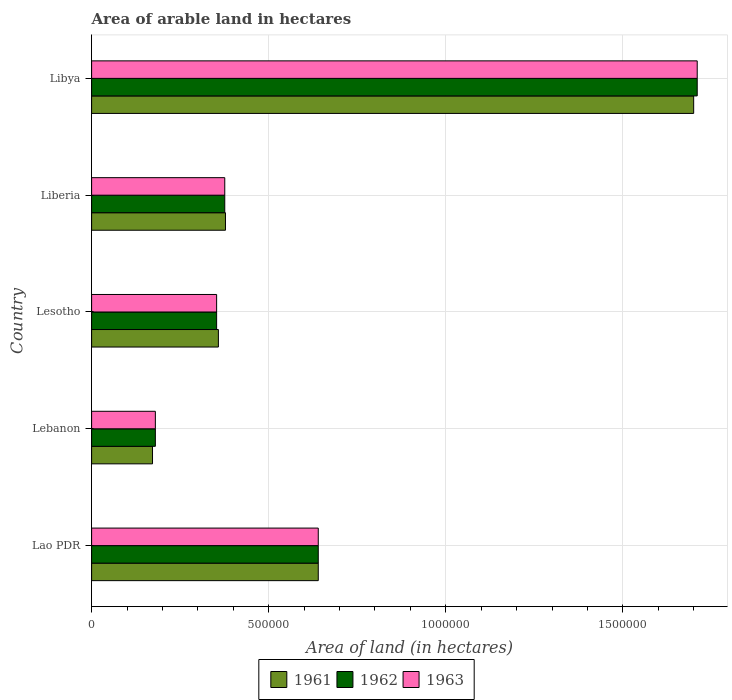How many different coloured bars are there?
Your answer should be very brief. 3. How many groups of bars are there?
Make the answer very short. 5. How many bars are there on the 4th tick from the top?
Your answer should be compact. 3. How many bars are there on the 3rd tick from the bottom?
Give a very brief answer. 3. What is the label of the 2nd group of bars from the top?
Offer a terse response. Liberia. In how many cases, is the number of bars for a given country not equal to the number of legend labels?
Provide a short and direct response. 0. What is the total arable land in 1962 in Libya?
Offer a terse response. 1.71e+06. Across all countries, what is the maximum total arable land in 1962?
Provide a succinct answer. 1.71e+06. Across all countries, what is the minimum total arable land in 1962?
Keep it short and to the point. 1.80e+05. In which country was the total arable land in 1962 maximum?
Your response must be concise. Libya. In which country was the total arable land in 1962 minimum?
Offer a very short reply. Lebanon. What is the total total arable land in 1962 in the graph?
Give a very brief answer. 3.26e+06. What is the difference between the total arable land in 1963 in Lesotho and that in Liberia?
Keep it short and to the point. -2.30e+04. What is the difference between the total arable land in 1962 in Lesotho and the total arable land in 1961 in Lebanon?
Ensure brevity in your answer.  1.81e+05. What is the average total arable land in 1962 per country?
Your answer should be very brief. 6.52e+05. In how many countries, is the total arable land in 1963 greater than 1600000 hectares?
Your answer should be very brief. 1. What is the ratio of the total arable land in 1963 in Lebanon to that in Libya?
Your response must be concise. 0.11. What is the difference between the highest and the second highest total arable land in 1963?
Provide a short and direct response. 1.07e+06. What is the difference between the highest and the lowest total arable land in 1961?
Offer a terse response. 1.53e+06. What does the 1st bar from the top in Liberia represents?
Give a very brief answer. 1963. How many bars are there?
Ensure brevity in your answer.  15. Are all the bars in the graph horizontal?
Give a very brief answer. Yes. How many countries are there in the graph?
Make the answer very short. 5. Are the values on the major ticks of X-axis written in scientific E-notation?
Offer a terse response. No. Does the graph contain grids?
Your answer should be very brief. Yes. Where does the legend appear in the graph?
Make the answer very short. Bottom center. How are the legend labels stacked?
Provide a short and direct response. Horizontal. What is the title of the graph?
Provide a succinct answer. Area of arable land in hectares. What is the label or title of the X-axis?
Keep it short and to the point. Area of land (in hectares). What is the label or title of the Y-axis?
Provide a succinct answer. Country. What is the Area of land (in hectares) in 1961 in Lao PDR?
Give a very brief answer. 6.40e+05. What is the Area of land (in hectares) in 1962 in Lao PDR?
Your answer should be compact. 6.40e+05. What is the Area of land (in hectares) of 1963 in Lao PDR?
Provide a short and direct response. 6.40e+05. What is the Area of land (in hectares) in 1961 in Lebanon?
Your answer should be very brief. 1.72e+05. What is the Area of land (in hectares) of 1962 in Lebanon?
Give a very brief answer. 1.80e+05. What is the Area of land (in hectares) in 1961 in Lesotho?
Provide a succinct answer. 3.58e+05. What is the Area of land (in hectares) of 1962 in Lesotho?
Keep it short and to the point. 3.53e+05. What is the Area of land (in hectares) in 1963 in Lesotho?
Make the answer very short. 3.53e+05. What is the Area of land (in hectares) in 1961 in Liberia?
Provide a short and direct response. 3.78e+05. What is the Area of land (in hectares) in 1962 in Liberia?
Give a very brief answer. 3.76e+05. What is the Area of land (in hectares) of 1963 in Liberia?
Ensure brevity in your answer.  3.76e+05. What is the Area of land (in hectares) in 1961 in Libya?
Your answer should be very brief. 1.70e+06. What is the Area of land (in hectares) in 1962 in Libya?
Give a very brief answer. 1.71e+06. What is the Area of land (in hectares) in 1963 in Libya?
Provide a succinct answer. 1.71e+06. Across all countries, what is the maximum Area of land (in hectares) in 1961?
Your response must be concise. 1.70e+06. Across all countries, what is the maximum Area of land (in hectares) in 1962?
Provide a succinct answer. 1.71e+06. Across all countries, what is the maximum Area of land (in hectares) in 1963?
Offer a terse response. 1.71e+06. Across all countries, what is the minimum Area of land (in hectares) of 1961?
Your response must be concise. 1.72e+05. Across all countries, what is the minimum Area of land (in hectares) in 1962?
Offer a terse response. 1.80e+05. What is the total Area of land (in hectares) of 1961 in the graph?
Ensure brevity in your answer.  3.25e+06. What is the total Area of land (in hectares) of 1962 in the graph?
Keep it short and to the point. 3.26e+06. What is the total Area of land (in hectares) in 1963 in the graph?
Offer a terse response. 3.26e+06. What is the difference between the Area of land (in hectares) of 1961 in Lao PDR and that in Lebanon?
Your answer should be compact. 4.68e+05. What is the difference between the Area of land (in hectares) in 1963 in Lao PDR and that in Lebanon?
Ensure brevity in your answer.  4.60e+05. What is the difference between the Area of land (in hectares) in 1961 in Lao PDR and that in Lesotho?
Keep it short and to the point. 2.82e+05. What is the difference between the Area of land (in hectares) of 1962 in Lao PDR and that in Lesotho?
Give a very brief answer. 2.87e+05. What is the difference between the Area of land (in hectares) in 1963 in Lao PDR and that in Lesotho?
Your response must be concise. 2.87e+05. What is the difference between the Area of land (in hectares) in 1961 in Lao PDR and that in Liberia?
Offer a terse response. 2.62e+05. What is the difference between the Area of land (in hectares) in 1962 in Lao PDR and that in Liberia?
Keep it short and to the point. 2.64e+05. What is the difference between the Area of land (in hectares) in 1963 in Lao PDR and that in Liberia?
Your answer should be very brief. 2.64e+05. What is the difference between the Area of land (in hectares) in 1961 in Lao PDR and that in Libya?
Keep it short and to the point. -1.06e+06. What is the difference between the Area of land (in hectares) in 1962 in Lao PDR and that in Libya?
Provide a short and direct response. -1.07e+06. What is the difference between the Area of land (in hectares) in 1963 in Lao PDR and that in Libya?
Provide a succinct answer. -1.07e+06. What is the difference between the Area of land (in hectares) of 1961 in Lebanon and that in Lesotho?
Give a very brief answer. -1.86e+05. What is the difference between the Area of land (in hectares) of 1962 in Lebanon and that in Lesotho?
Make the answer very short. -1.73e+05. What is the difference between the Area of land (in hectares) in 1963 in Lebanon and that in Lesotho?
Your answer should be very brief. -1.73e+05. What is the difference between the Area of land (in hectares) in 1961 in Lebanon and that in Liberia?
Ensure brevity in your answer.  -2.06e+05. What is the difference between the Area of land (in hectares) of 1962 in Lebanon and that in Liberia?
Your response must be concise. -1.96e+05. What is the difference between the Area of land (in hectares) in 1963 in Lebanon and that in Liberia?
Your response must be concise. -1.96e+05. What is the difference between the Area of land (in hectares) of 1961 in Lebanon and that in Libya?
Offer a terse response. -1.53e+06. What is the difference between the Area of land (in hectares) of 1962 in Lebanon and that in Libya?
Ensure brevity in your answer.  -1.53e+06. What is the difference between the Area of land (in hectares) in 1963 in Lebanon and that in Libya?
Your answer should be very brief. -1.53e+06. What is the difference between the Area of land (in hectares) of 1962 in Lesotho and that in Liberia?
Keep it short and to the point. -2.30e+04. What is the difference between the Area of land (in hectares) in 1963 in Lesotho and that in Liberia?
Keep it short and to the point. -2.30e+04. What is the difference between the Area of land (in hectares) in 1961 in Lesotho and that in Libya?
Provide a short and direct response. -1.34e+06. What is the difference between the Area of land (in hectares) of 1962 in Lesotho and that in Libya?
Give a very brief answer. -1.36e+06. What is the difference between the Area of land (in hectares) of 1963 in Lesotho and that in Libya?
Offer a very short reply. -1.36e+06. What is the difference between the Area of land (in hectares) in 1961 in Liberia and that in Libya?
Offer a very short reply. -1.32e+06. What is the difference between the Area of land (in hectares) of 1962 in Liberia and that in Libya?
Keep it short and to the point. -1.33e+06. What is the difference between the Area of land (in hectares) in 1963 in Liberia and that in Libya?
Provide a succinct answer. -1.33e+06. What is the difference between the Area of land (in hectares) of 1961 in Lao PDR and the Area of land (in hectares) of 1962 in Lebanon?
Your response must be concise. 4.60e+05. What is the difference between the Area of land (in hectares) in 1961 in Lao PDR and the Area of land (in hectares) in 1963 in Lebanon?
Provide a succinct answer. 4.60e+05. What is the difference between the Area of land (in hectares) of 1961 in Lao PDR and the Area of land (in hectares) of 1962 in Lesotho?
Make the answer very short. 2.87e+05. What is the difference between the Area of land (in hectares) in 1961 in Lao PDR and the Area of land (in hectares) in 1963 in Lesotho?
Ensure brevity in your answer.  2.87e+05. What is the difference between the Area of land (in hectares) in 1962 in Lao PDR and the Area of land (in hectares) in 1963 in Lesotho?
Ensure brevity in your answer.  2.87e+05. What is the difference between the Area of land (in hectares) of 1961 in Lao PDR and the Area of land (in hectares) of 1962 in Liberia?
Give a very brief answer. 2.64e+05. What is the difference between the Area of land (in hectares) in 1961 in Lao PDR and the Area of land (in hectares) in 1963 in Liberia?
Give a very brief answer. 2.64e+05. What is the difference between the Area of land (in hectares) of 1962 in Lao PDR and the Area of land (in hectares) of 1963 in Liberia?
Make the answer very short. 2.64e+05. What is the difference between the Area of land (in hectares) of 1961 in Lao PDR and the Area of land (in hectares) of 1962 in Libya?
Offer a very short reply. -1.07e+06. What is the difference between the Area of land (in hectares) of 1961 in Lao PDR and the Area of land (in hectares) of 1963 in Libya?
Your answer should be compact. -1.07e+06. What is the difference between the Area of land (in hectares) of 1962 in Lao PDR and the Area of land (in hectares) of 1963 in Libya?
Your response must be concise. -1.07e+06. What is the difference between the Area of land (in hectares) in 1961 in Lebanon and the Area of land (in hectares) in 1962 in Lesotho?
Offer a very short reply. -1.81e+05. What is the difference between the Area of land (in hectares) of 1961 in Lebanon and the Area of land (in hectares) of 1963 in Lesotho?
Offer a very short reply. -1.81e+05. What is the difference between the Area of land (in hectares) in 1962 in Lebanon and the Area of land (in hectares) in 1963 in Lesotho?
Ensure brevity in your answer.  -1.73e+05. What is the difference between the Area of land (in hectares) of 1961 in Lebanon and the Area of land (in hectares) of 1962 in Liberia?
Give a very brief answer. -2.04e+05. What is the difference between the Area of land (in hectares) in 1961 in Lebanon and the Area of land (in hectares) in 1963 in Liberia?
Provide a succinct answer. -2.04e+05. What is the difference between the Area of land (in hectares) in 1962 in Lebanon and the Area of land (in hectares) in 1963 in Liberia?
Your answer should be very brief. -1.96e+05. What is the difference between the Area of land (in hectares) in 1961 in Lebanon and the Area of land (in hectares) in 1962 in Libya?
Keep it short and to the point. -1.54e+06. What is the difference between the Area of land (in hectares) of 1961 in Lebanon and the Area of land (in hectares) of 1963 in Libya?
Offer a terse response. -1.54e+06. What is the difference between the Area of land (in hectares) of 1962 in Lebanon and the Area of land (in hectares) of 1963 in Libya?
Your answer should be compact. -1.53e+06. What is the difference between the Area of land (in hectares) in 1961 in Lesotho and the Area of land (in hectares) in 1962 in Liberia?
Provide a succinct answer. -1.80e+04. What is the difference between the Area of land (in hectares) of 1961 in Lesotho and the Area of land (in hectares) of 1963 in Liberia?
Provide a short and direct response. -1.80e+04. What is the difference between the Area of land (in hectares) of 1962 in Lesotho and the Area of land (in hectares) of 1963 in Liberia?
Keep it short and to the point. -2.30e+04. What is the difference between the Area of land (in hectares) of 1961 in Lesotho and the Area of land (in hectares) of 1962 in Libya?
Make the answer very short. -1.35e+06. What is the difference between the Area of land (in hectares) in 1961 in Lesotho and the Area of land (in hectares) in 1963 in Libya?
Your answer should be very brief. -1.35e+06. What is the difference between the Area of land (in hectares) of 1962 in Lesotho and the Area of land (in hectares) of 1963 in Libya?
Your answer should be very brief. -1.36e+06. What is the difference between the Area of land (in hectares) in 1961 in Liberia and the Area of land (in hectares) in 1962 in Libya?
Provide a succinct answer. -1.33e+06. What is the difference between the Area of land (in hectares) of 1961 in Liberia and the Area of land (in hectares) of 1963 in Libya?
Provide a succinct answer. -1.33e+06. What is the difference between the Area of land (in hectares) in 1962 in Liberia and the Area of land (in hectares) in 1963 in Libya?
Your answer should be compact. -1.33e+06. What is the average Area of land (in hectares) of 1961 per country?
Make the answer very short. 6.50e+05. What is the average Area of land (in hectares) in 1962 per country?
Give a very brief answer. 6.52e+05. What is the average Area of land (in hectares) in 1963 per country?
Ensure brevity in your answer.  6.52e+05. What is the difference between the Area of land (in hectares) in 1961 and Area of land (in hectares) in 1962 in Lao PDR?
Provide a short and direct response. 0. What is the difference between the Area of land (in hectares) in 1961 and Area of land (in hectares) in 1963 in Lao PDR?
Your answer should be compact. 0. What is the difference between the Area of land (in hectares) of 1962 and Area of land (in hectares) of 1963 in Lao PDR?
Offer a terse response. 0. What is the difference between the Area of land (in hectares) of 1961 and Area of land (in hectares) of 1962 in Lebanon?
Your answer should be very brief. -8000. What is the difference between the Area of land (in hectares) of 1961 and Area of land (in hectares) of 1963 in Lebanon?
Offer a very short reply. -8000. What is the difference between the Area of land (in hectares) of 1962 and Area of land (in hectares) of 1963 in Lebanon?
Make the answer very short. 0. What is the difference between the Area of land (in hectares) in 1961 and Area of land (in hectares) in 1962 in Lesotho?
Ensure brevity in your answer.  5000. What is the difference between the Area of land (in hectares) in 1961 and Area of land (in hectares) in 1963 in Lesotho?
Offer a terse response. 5000. What is the difference between the Area of land (in hectares) in 1962 and Area of land (in hectares) in 1963 in Lesotho?
Make the answer very short. 0. What is the difference between the Area of land (in hectares) in 1961 and Area of land (in hectares) in 1962 in Liberia?
Your answer should be compact. 2000. What is the difference between the Area of land (in hectares) of 1961 and Area of land (in hectares) of 1963 in Liberia?
Offer a terse response. 2000. What is the difference between the Area of land (in hectares) in 1961 and Area of land (in hectares) in 1963 in Libya?
Provide a short and direct response. -10000. What is the ratio of the Area of land (in hectares) of 1961 in Lao PDR to that in Lebanon?
Your answer should be very brief. 3.72. What is the ratio of the Area of land (in hectares) of 1962 in Lao PDR to that in Lebanon?
Provide a succinct answer. 3.56. What is the ratio of the Area of land (in hectares) in 1963 in Lao PDR to that in Lebanon?
Your answer should be compact. 3.56. What is the ratio of the Area of land (in hectares) of 1961 in Lao PDR to that in Lesotho?
Your response must be concise. 1.79. What is the ratio of the Area of land (in hectares) in 1962 in Lao PDR to that in Lesotho?
Your answer should be compact. 1.81. What is the ratio of the Area of land (in hectares) of 1963 in Lao PDR to that in Lesotho?
Your answer should be very brief. 1.81. What is the ratio of the Area of land (in hectares) of 1961 in Lao PDR to that in Liberia?
Offer a terse response. 1.69. What is the ratio of the Area of land (in hectares) of 1962 in Lao PDR to that in Liberia?
Provide a short and direct response. 1.7. What is the ratio of the Area of land (in hectares) in 1963 in Lao PDR to that in Liberia?
Provide a short and direct response. 1.7. What is the ratio of the Area of land (in hectares) of 1961 in Lao PDR to that in Libya?
Ensure brevity in your answer.  0.38. What is the ratio of the Area of land (in hectares) in 1962 in Lao PDR to that in Libya?
Make the answer very short. 0.37. What is the ratio of the Area of land (in hectares) in 1963 in Lao PDR to that in Libya?
Provide a succinct answer. 0.37. What is the ratio of the Area of land (in hectares) of 1961 in Lebanon to that in Lesotho?
Provide a succinct answer. 0.48. What is the ratio of the Area of land (in hectares) of 1962 in Lebanon to that in Lesotho?
Ensure brevity in your answer.  0.51. What is the ratio of the Area of land (in hectares) of 1963 in Lebanon to that in Lesotho?
Make the answer very short. 0.51. What is the ratio of the Area of land (in hectares) in 1961 in Lebanon to that in Liberia?
Your answer should be very brief. 0.46. What is the ratio of the Area of land (in hectares) in 1962 in Lebanon to that in Liberia?
Give a very brief answer. 0.48. What is the ratio of the Area of land (in hectares) of 1963 in Lebanon to that in Liberia?
Provide a short and direct response. 0.48. What is the ratio of the Area of land (in hectares) in 1961 in Lebanon to that in Libya?
Offer a very short reply. 0.1. What is the ratio of the Area of land (in hectares) of 1962 in Lebanon to that in Libya?
Your answer should be compact. 0.11. What is the ratio of the Area of land (in hectares) in 1963 in Lebanon to that in Libya?
Your answer should be very brief. 0.11. What is the ratio of the Area of land (in hectares) in 1961 in Lesotho to that in Liberia?
Offer a very short reply. 0.95. What is the ratio of the Area of land (in hectares) of 1962 in Lesotho to that in Liberia?
Your response must be concise. 0.94. What is the ratio of the Area of land (in hectares) of 1963 in Lesotho to that in Liberia?
Ensure brevity in your answer.  0.94. What is the ratio of the Area of land (in hectares) of 1961 in Lesotho to that in Libya?
Your answer should be very brief. 0.21. What is the ratio of the Area of land (in hectares) of 1962 in Lesotho to that in Libya?
Your response must be concise. 0.21. What is the ratio of the Area of land (in hectares) in 1963 in Lesotho to that in Libya?
Your answer should be compact. 0.21. What is the ratio of the Area of land (in hectares) in 1961 in Liberia to that in Libya?
Give a very brief answer. 0.22. What is the ratio of the Area of land (in hectares) in 1962 in Liberia to that in Libya?
Ensure brevity in your answer.  0.22. What is the ratio of the Area of land (in hectares) of 1963 in Liberia to that in Libya?
Provide a short and direct response. 0.22. What is the difference between the highest and the second highest Area of land (in hectares) in 1961?
Make the answer very short. 1.06e+06. What is the difference between the highest and the second highest Area of land (in hectares) in 1962?
Offer a terse response. 1.07e+06. What is the difference between the highest and the second highest Area of land (in hectares) of 1963?
Your answer should be very brief. 1.07e+06. What is the difference between the highest and the lowest Area of land (in hectares) of 1961?
Ensure brevity in your answer.  1.53e+06. What is the difference between the highest and the lowest Area of land (in hectares) in 1962?
Provide a succinct answer. 1.53e+06. What is the difference between the highest and the lowest Area of land (in hectares) in 1963?
Provide a short and direct response. 1.53e+06. 